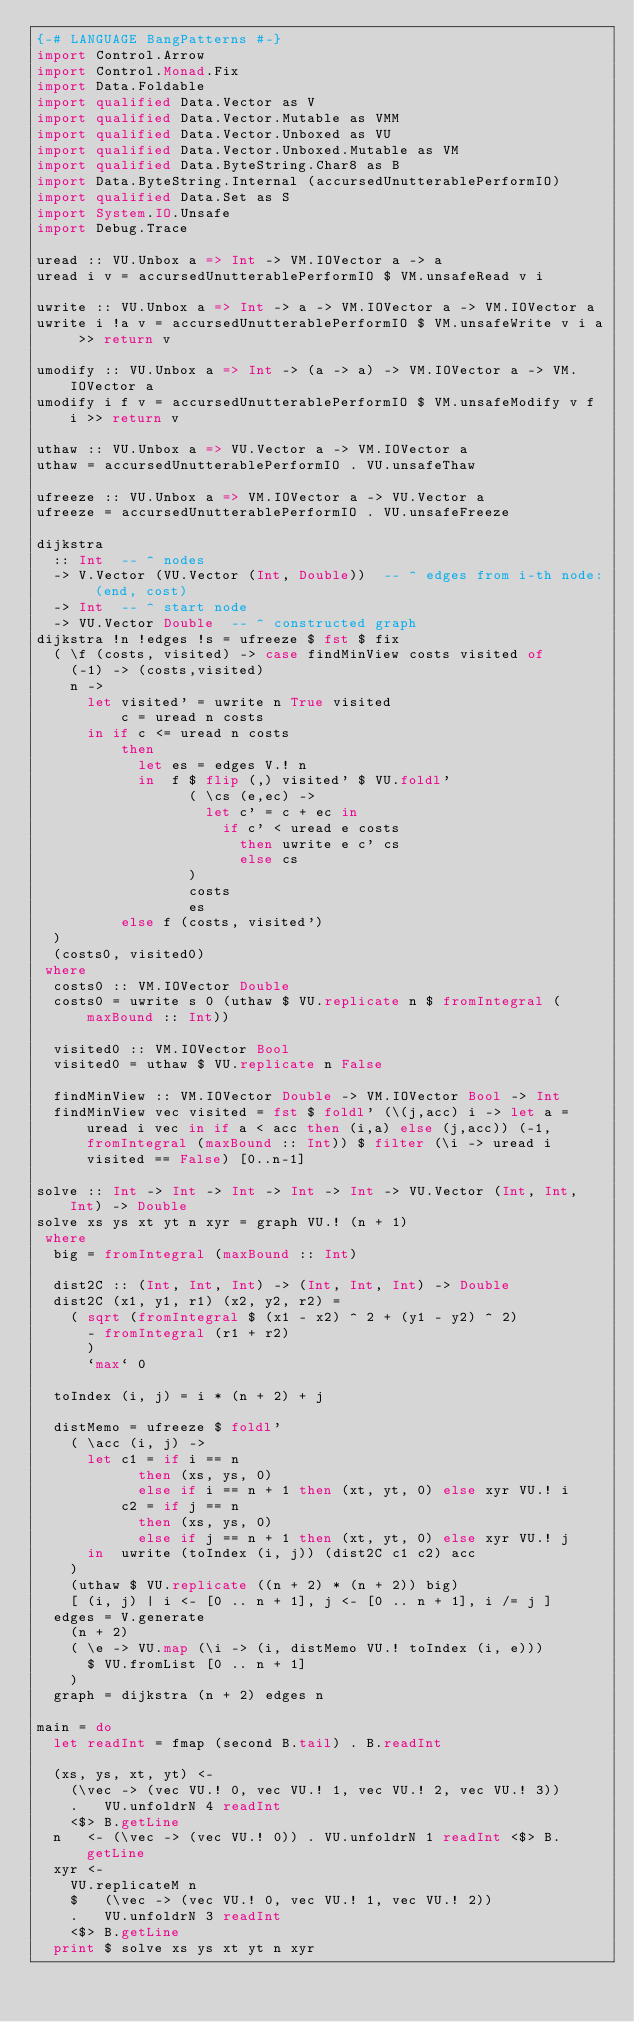<code> <loc_0><loc_0><loc_500><loc_500><_Haskell_>{-# LANGUAGE BangPatterns #-}
import Control.Arrow
import Control.Monad.Fix
import Data.Foldable
import qualified Data.Vector as V
import qualified Data.Vector.Mutable as VMM
import qualified Data.Vector.Unboxed as VU
import qualified Data.Vector.Unboxed.Mutable as VM
import qualified Data.ByteString.Char8 as B
import Data.ByteString.Internal (accursedUnutterablePerformIO)
import qualified Data.Set as S
import System.IO.Unsafe
import Debug.Trace

uread :: VU.Unbox a => Int -> VM.IOVector a -> a
uread i v = accursedUnutterablePerformIO $ VM.unsafeRead v i

uwrite :: VU.Unbox a => Int -> a -> VM.IOVector a -> VM.IOVector a
uwrite i !a v = accursedUnutterablePerformIO $ VM.unsafeWrite v i a >> return v

umodify :: VU.Unbox a => Int -> (a -> a) -> VM.IOVector a -> VM.IOVector a
umodify i f v = accursedUnutterablePerformIO $ VM.unsafeModify v f i >> return v

uthaw :: VU.Unbox a => VU.Vector a -> VM.IOVector a
uthaw = accursedUnutterablePerformIO . VU.unsafeThaw

ufreeze :: VU.Unbox a => VM.IOVector a -> VU.Vector a
ufreeze = accursedUnutterablePerformIO . VU.unsafeFreeze

dijkstra
  :: Int  -- ^ nodes
  -> V.Vector (VU.Vector (Int, Double))  -- ^ edges from i-th node: (end, cost)
  -> Int  -- ^ start node
  -> VU.Vector Double  -- ^ constructed graph
dijkstra !n !edges !s = ufreeze $ fst $ fix
  ( \f (costs, visited) -> case findMinView costs visited of
    (-1) -> (costs,visited)
    n ->
      let visited' = uwrite n True visited
          c = uread n costs
      in if c <= uread n costs
          then
            let es = edges V.! n
            in  f $ flip (,) visited' $ VU.foldl'
                  ( \cs (e,ec) ->
                    let c' = c + ec in 
                      if c' < uread e costs
                        then uwrite e c' cs
                        else cs
                  )
                  costs
                  es
          else f (costs, visited')
  )
  (costs0, visited0)
 where
  costs0 :: VM.IOVector Double
  costs0 = uwrite s 0 (uthaw $ VU.replicate n $ fromIntegral (maxBound :: Int))

  visited0 :: VM.IOVector Bool
  visited0 = uthaw $ VU.replicate n False

  findMinView :: VM.IOVector Double -> VM.IOVector Bool -> Int
  findMinView vec visited = fst $ foldl' (\(j,acc) i -> let a = uread i vec in if a < acc then (i,a) else (j,acc)) (-1,fromIntegral (maxBound :: Int)) $ filter (\i -> uread i visited == False) [0..n-1]

solve :: Int -> Int -> Int -> Int -> Int -> VU.Vector (Int, Int, Int) -> Double
solve xs ys xt yt n xyr = graph VU.! (n + 1)
 where
  big = fromIntegral (maxBound :: Int)

  dist2C :: (Int, Int, Int) -> (Int, Int, Int) -> Double
  dist2C (x1, y1, r1) (x2, y2, r2) =
    ( sqrt (fromIntegral $ (x1 - x2) ^ 2 + (y1 - y2) ^ 2)
      - fromIntegral (r1 + r2)
      )
      `max` 0

  toIndex (i, j) = i * (n + 2) + j

  distMemo = ufreeze $ foldl'
    ( \acc (i, j) ->
      let c1 = if i == n
            then (xs, ys, 0)
            else if i == n + 1 then (xt, yt, 0) else xyr VU.! i
          c2 = if j == n
            then (xs, ys, 0)
            else if j == n + 1 then (xt, yt, 0) else xyr VU.! j
      in  uwrite (toIndex (i, j)) (dist2C c1 c2) acc
    )
    (uthaw $ VU.replicate ((n + 2) * (n + 2)) big)
    [ (i, j) | i <- [0 .. n + 1], j <- [0 .. n + 1], i /= j ]
  edges = V.generate
    (n + 2)
    ( \e -> VU.map (\i -> (i, distMemo VU.! toIndex (i, e)))
      $ VU.fromList [0 .. n + 1]
    )
  graph = dijkstra (n + 2) edges n

main = do
  let readInt = fmap (second B.tail) . B.readInt

  (xs, ys, xt, yt) <-
    (\vec -> (vec VU.! 0, vec VU.! 1, vec VU.! 2, vec VU.! 3))
    .   VU.unfoldrN 4 readInt
    <$> B.getLine
  n   <- (\vec -> (vec VU.! 0)) . VU.unfoldrN 1 readInt <$> B.getLine
  xyr <-
    VU.replicateM n
    $   (\vec -> (vec VU.! 0, vec VU.! 1, vec VU.! 2))
    .   VU.unfoldrN 3 readInt
    <$> B.getLine
  print $ solve xs ys xt yt n xyr
</code> 